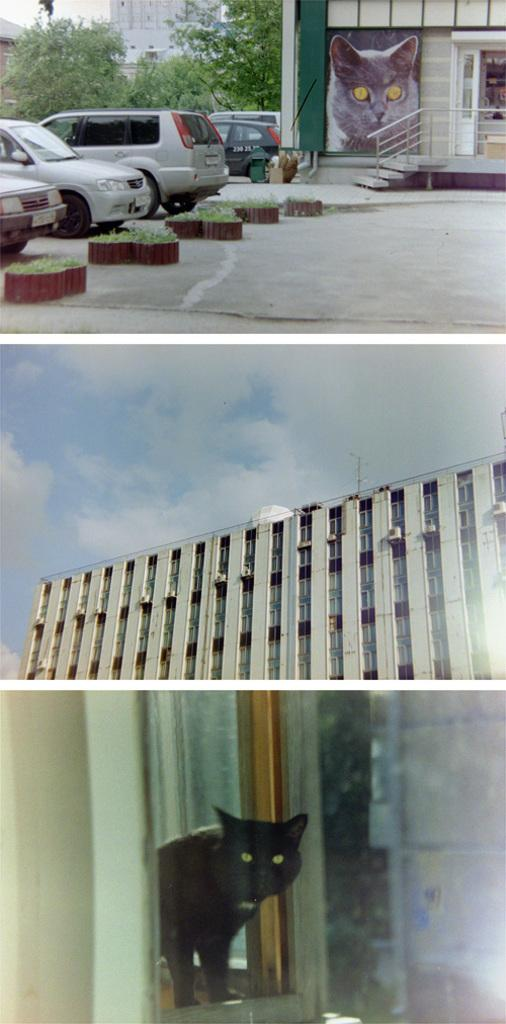What type of artwork is the image? The image is a collage. Can you describe a specific element in the collage? There is a cat peeking through a window in the image. What type of structures can be seen in the collage? There are buildings in the image. What architectural feature is present in the collage? There are stairs in the image. What mode of transportation is visible in the collage? There are vehicles in the image. What type of vegetation is present in the collage? There are trees in the image. What part of the natural environment is visible in the collage? The sky is visible in the image. What type of paper is the cat using to write a letter in the image? There is no paper or letter-writing activity present in the image; it features a cat peeking through a window in a collage. What kind of pet is visible on the edge of the collage? There is no pet visible on the edge of the collage; the only pet mentioned is the cat peeking through a window. 